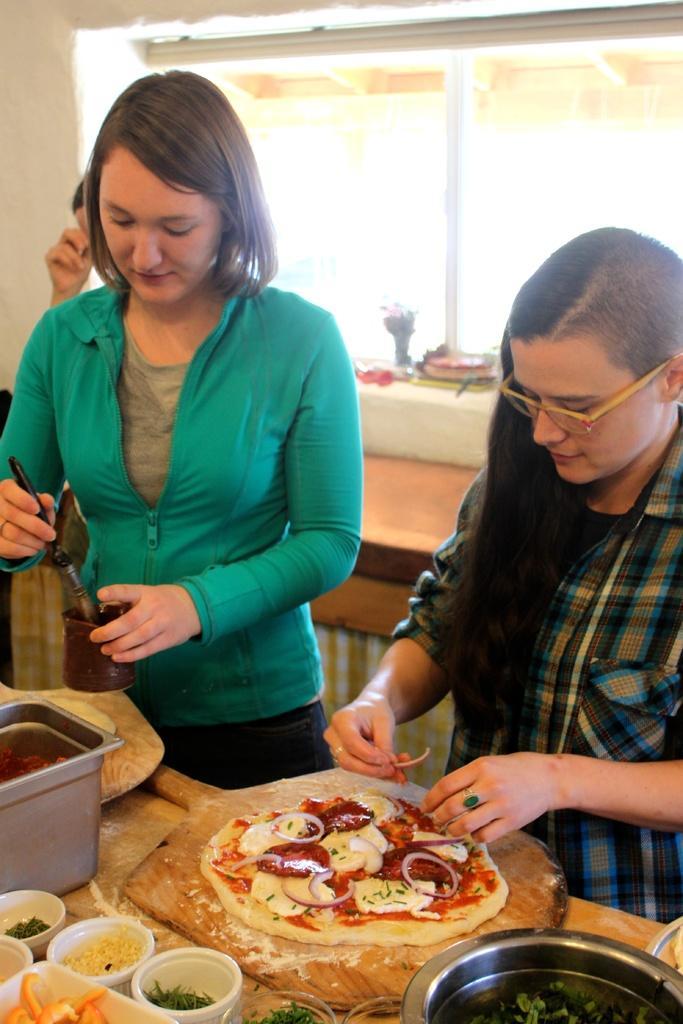Could you give a brief overview of what you see in this image? In this image, we can see two women are holding some items. At the bottom, there is a wooden table. On top of that we few eatables things in bowls and wooden boards. Here we can see containers. Background we can see wall, window, curtains and person's hand. 